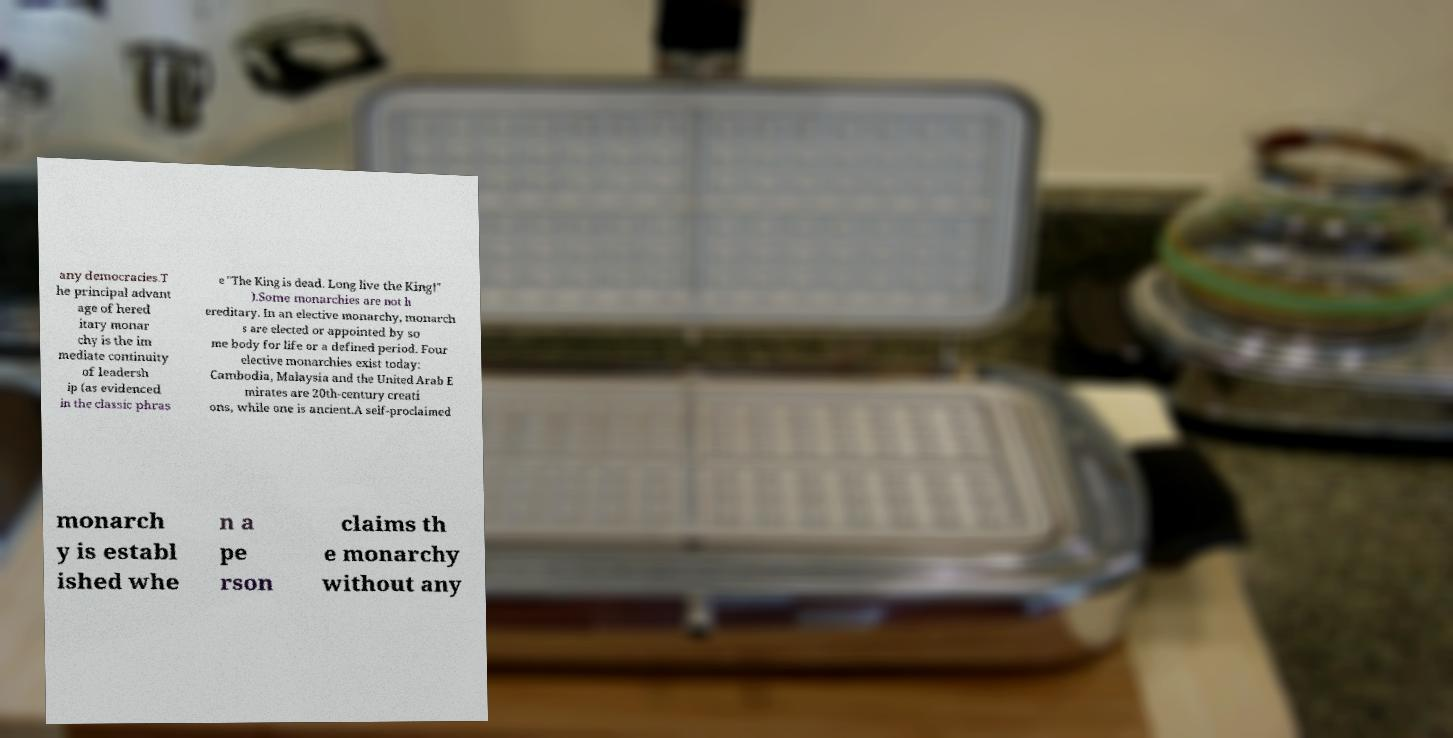There's text embedded in this image that I need extracted. Can you transcribe it verbatim? any democracies.T he principal advant age of hered itary monar chy is the im mediate continuity of leadersh ip (as evidenced in the classic phras e "The King is dead. Long live the King!" ).Some monarchies are not h ereditary. In an elective monarchy, monarch s are elected or appointed by so me body for life or a defined period. Four elective monarchies exist today: Cambodia, Malaysia and the United Arab E mirates are 20th-century creati ons, while one is ancient.A self-proclaimed monarch y is establ ished whe n a pe rson claims th e monarchy without any 